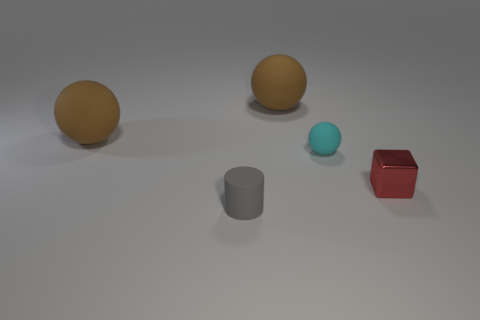Subtract all big brown rubber balls. How many balls are left? 1 Add 2 large brown rubber cylinders. How many objects exist? 7 Subtract all cubes. How many objects are left? 4 Subtract 0 blue cylinders. How many objects are left? 5 Subtract all tiny green shiny balls. Subtract all red blocks. How many objects are left? 4 Add 4 red metal things. How many red metal things are left? 5 Add 1 matte cylinders. How many matte cylinders exist? 2 